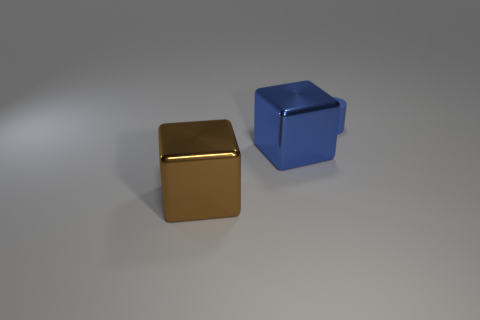What number of blocks are either brown metal things or large blue metallic objects?
Give a very brief answer. 2. There is a large thing that is made of the same material as the large brown cube; what color is it?
Your answer should be very brief. Blue. Are there fewer tiny purple matte cubes than blue cylinders?
Provide a short and direct response. Yes. There is a blue thing that is in front of the blue matte thing; is it the same shape as the large brown thing that is on the left side of the large blue object?
Your response must be concise. Yes. What number of things are brown shiny objects or small yellow metal objects?
Your answer should be compact. 1. The other metallic object that is the same size as the brown metallic object is what color?
Offer a terse response. Blue. What number of small blue rubber cylinders are in front of the blue thing that is left of the blue cylinder?
Offer a very short reply. 0. How many blue objects are right of the large blue thing and in front of the tiny blue object?
Your answer should be very brief. 0. What number of objects are either shiny objects right of the big brown block or metal cubes that are behind the brown object?
Make the answer very short. 1. What number of other objects are the same size as the blue cylinder?
Provide a short and direct response. 0. 